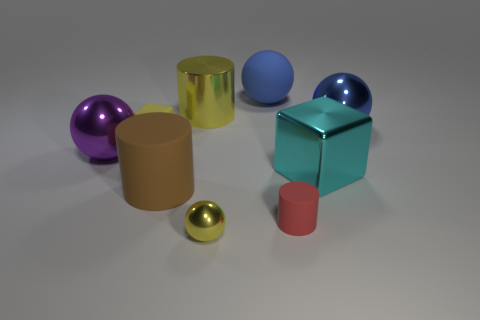Add 1 small red rubber cylinders. How many objects exist? 10 Subtract all spheres. How many objects are left? 5 Add 5 small metallic spheres. How many small metallic spheres are left? 6 Add 8 small yellow blocks. How many small yellow blocks exist? 9 Subtract 0 cyan cylinders. How many objects are left? 9 Subtract all big cyan objects. Subtract all yellow spheres. How many objects are left? 7 